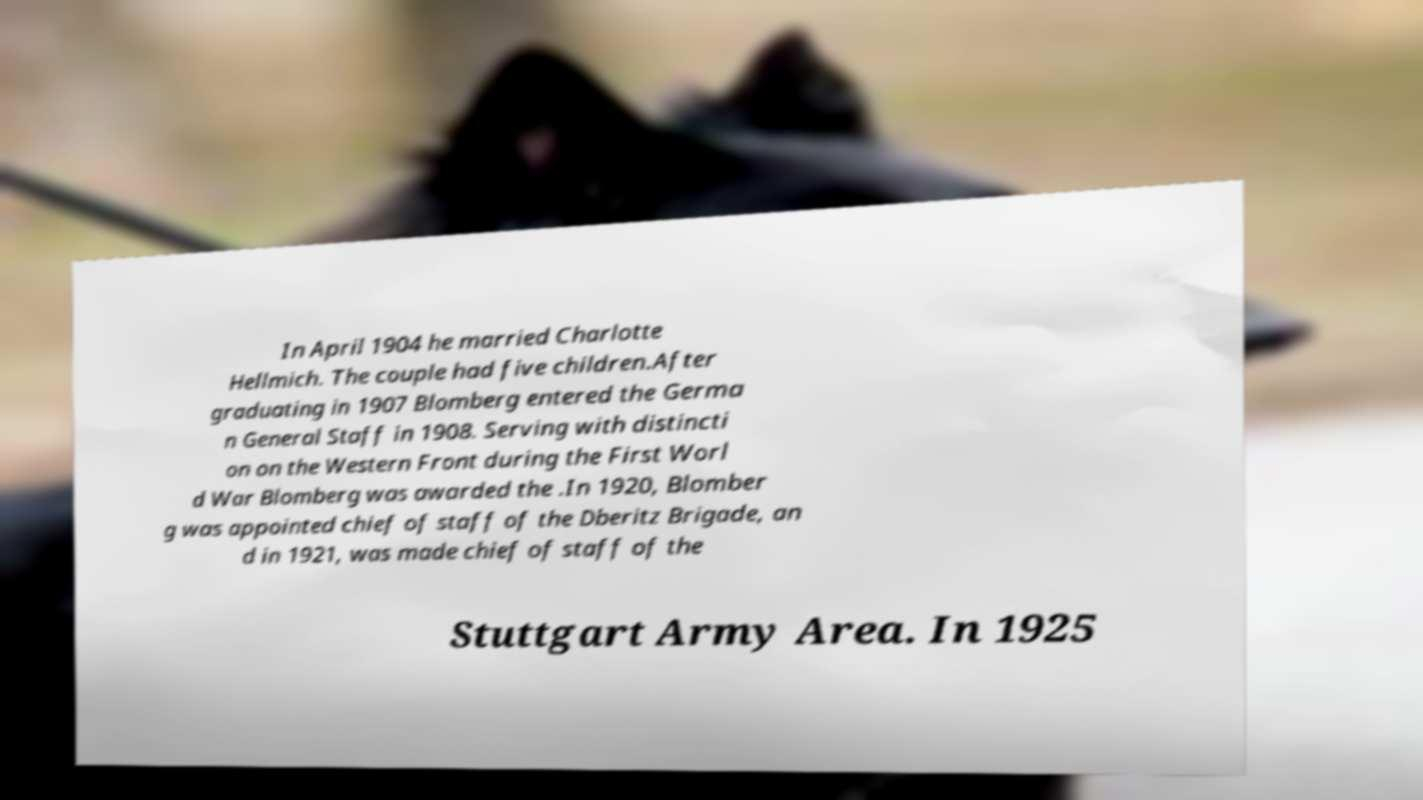Can you read and provide the text displayed in the image?This photo seems to have some interesting text. Can you extract and type it out for me? In April 1904 he married Charlotte Hellmich. The couple had five children.After graduating in 1907 Blomberg entered the Germa n General Staff in 1908. Serving with distincti on on the Western Front during the First Worl d War Blomberg was awarded the .In 1920, Blomber g was appointed chief of staff of the Dberitz Brigade, an d in 1921, was made chief of staff of the Stuttgart Army Area. In 1925 